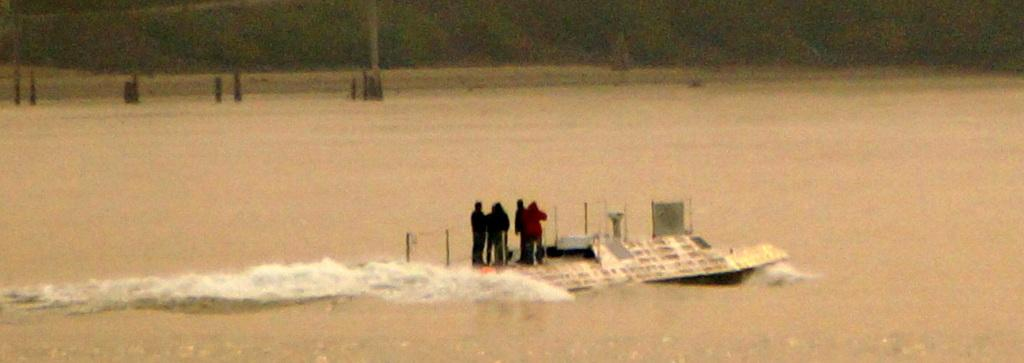What is the condition of the area in the image? The area in the image appears to be flooded. How high is the water in the image? The water is at a level that covers the ground. Where are the people in the image located? The people in the image are standing on the roof of a house. What type of sticks are being used by the people to play in the water? There are no sticks or any play activity visible in the image; the people are standing on the roof of a house due to the flooding. 